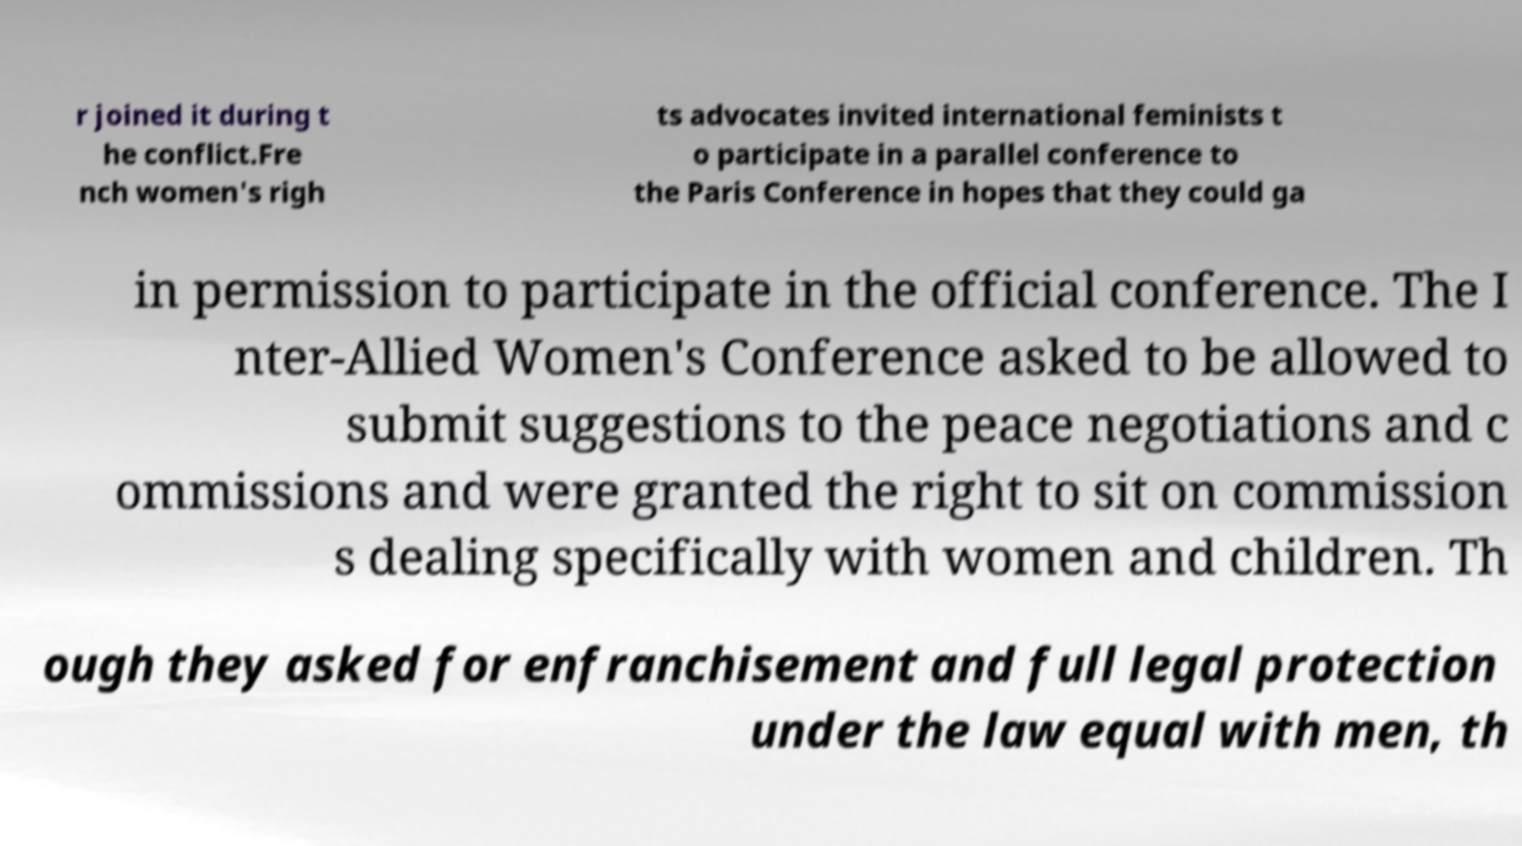Can you accurately transcribe the text from the provided image for me? r joined it during t he conflict.Fre nch women's righ ts advocates invited international feminists t o participate in a parallel conference to the Paris Conference in hopes that they could ga in permission to participate in the official conference. The I nter-Allied Women's Conference asked to be allowed to submit suggestions to the peace negotiations and c ommissions and were granted the right to sit on commission s dealing specifically with women and children. Th ough they asked for enfranchisement and full legal protection under the law equal with men, th 